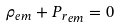Convert formula to latex. <formula><loc_0><loc_0><loc_500><loc_500>\rho _ { e m } + { P _ { r } } _ { e m } = 0</formula> 